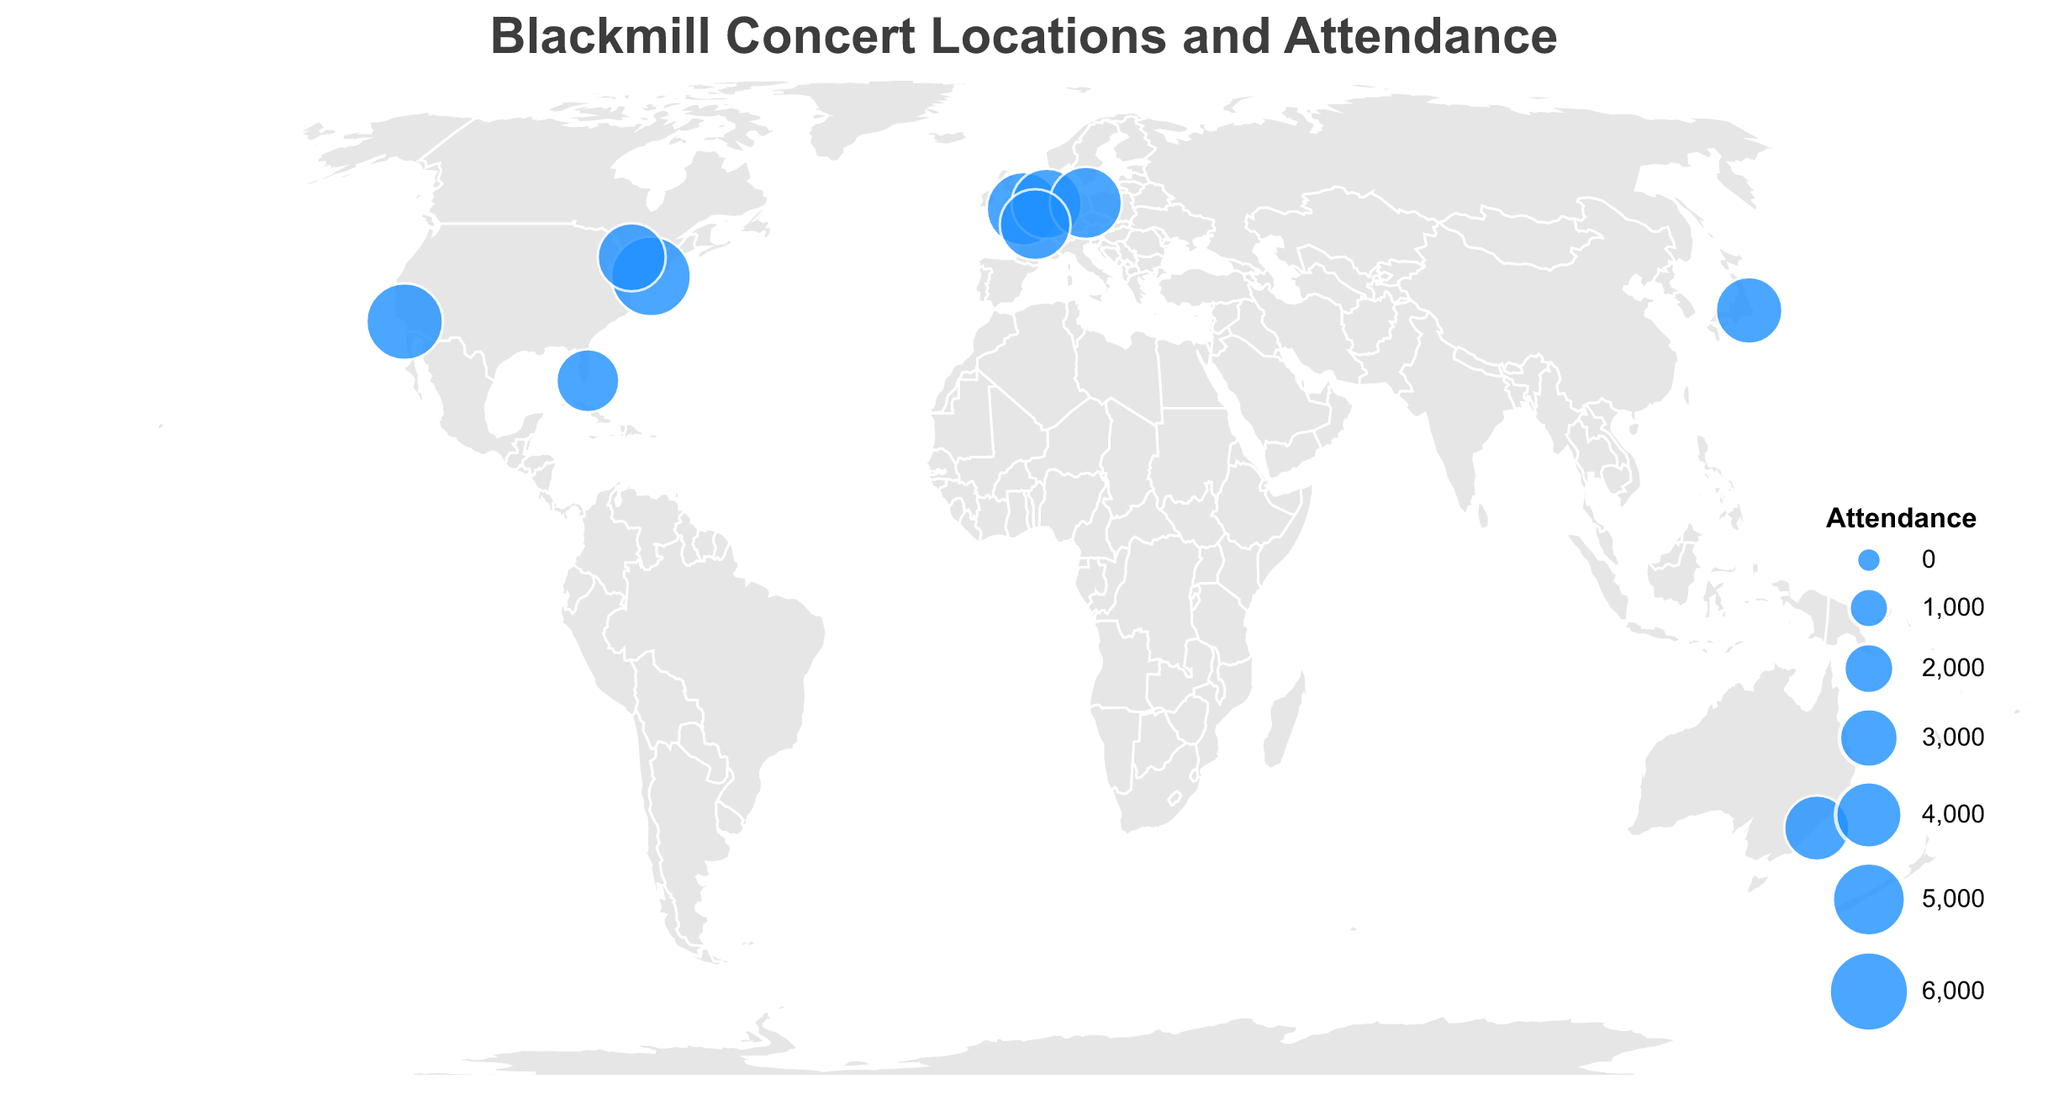What's the title of the plot? The title is directly located at the top of the plot and is visually prominent. It states the main subject of the visualization.
Answer: Blackmill Concert Locations and Attendance Which city had the highest attendance? By looking at the sizes of the circles representing each location's attendance, the largest circle indicates the highest attendance.
Answer: New York City How many locations had an attendance of more than 4500? We need to count the number of circles that are relatively larger and fall into the criteria of more than 4500 attendance. The cities with larger circles indicating higher attendance are: London (5000), New York City (6000), Berlin (4800), Los Angeles (5500), Paris (4600).
Answer: Five locations What is the combined attendance of the concerts in Tokyo and Sydney? To find the combined attendance, sum up the attendance values for Tokyo and Sydney. Tokyo has 4000 and Sydney has 3800, so 4000 + 3800 = 7800.
Answer: 7800 Which city had the lowest attendance? By checking the smallest circle on the plot, we can identify the city with the lowest attendance.
Answer: Miami Are there more European cities or North American cities plotted? To determine this, count the European cities (London, Amsterdam, Berlin, Paris) and North American cities (New York City, Los Angeles, Toronto, Miami). Europe has 4 cities and North America has 4 cities. Thus, they are equal.
Answer: They are equal What is the average attendance for the European concert locations? To calculate the average attendance for the concerts held in Europe, first, sum up the attendance values of the European cities (London, Amsterdam, Berlin, Paris). Then divide by the number of cities: \[(5000 + 4500 + 4800 + 4600) / 4 = 18900 / 4 = 4725\].
Answer: 4725 Which city in Europe had the highest attendance? Check the attendance numbers of the European cities and identify the one with the highest number: London (5000), Amsterdam (4500), Berlin (4800), Paris (4600). The highest value is for London.
Answer: London Between Los Angeles and Toronto, which location had higher attendance and by how much? Compare the attendance numbers for these two cities: Los Angeles has 5500, and Toronto has 4200. The difference is 5500 - 4200 = 1300.
Answer: Los Angeles by 1300 Is there any concert located in the Southern Hemisphere? Look at the latitude values. Any location with a negative latitude is in the Southern Hemisphere. Only Sydney has a negative latitude value (-33.8688).
Answer: Yes, Sydney 